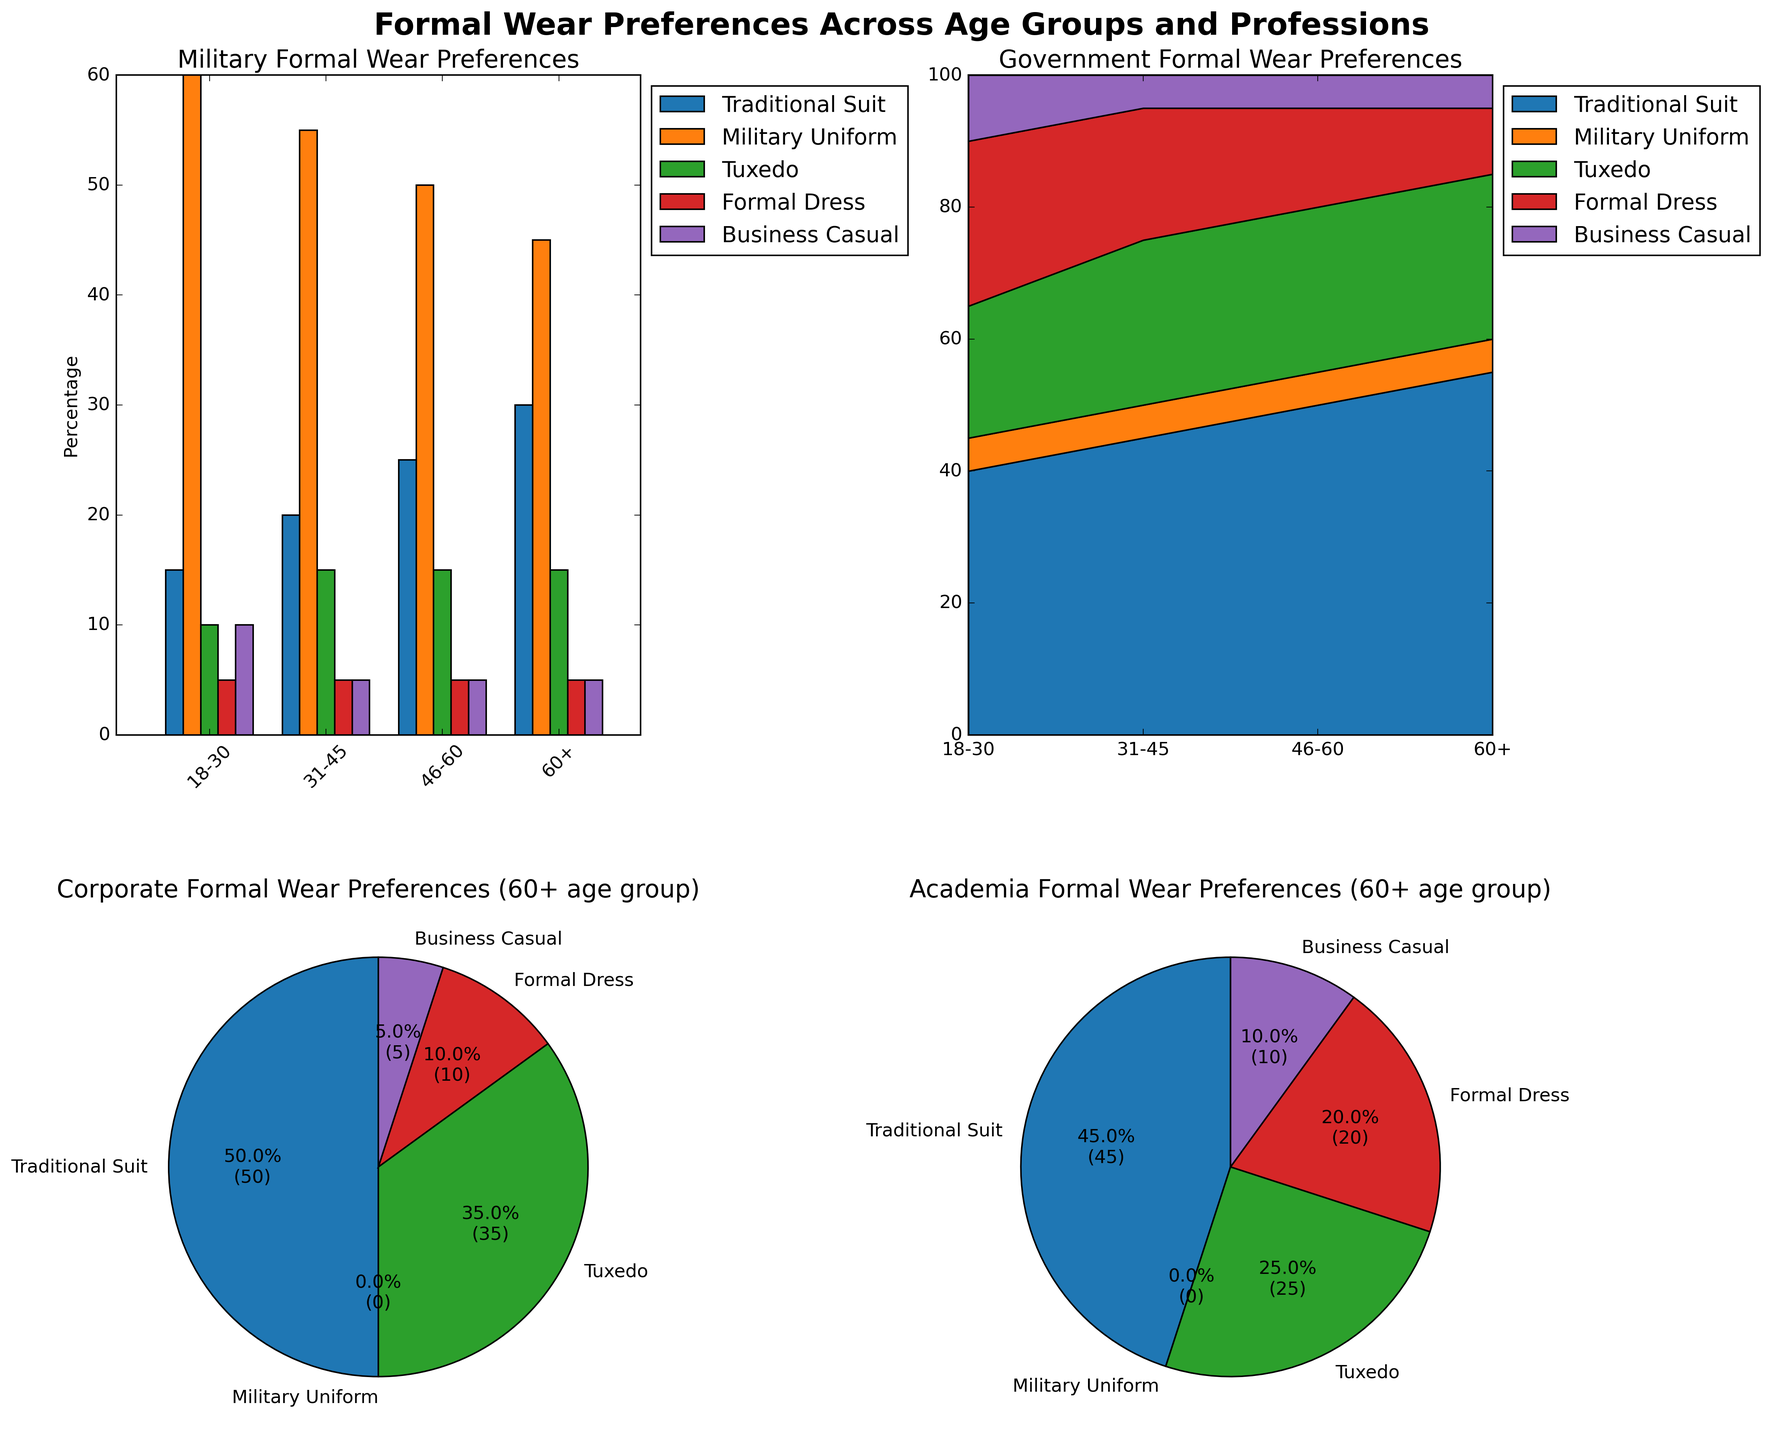What is the title of the figure portraying military preferences? Look at the title directly on the subplot located in the top-left corner, which describes military preferences in formal wear
Answer: Military Formal Wear Preferences For the Military profession, which age group shows the highest preference for a traditional suit? Examine the bar heights corresponding to the category 'Traditional Suit' in the bar plot for different age groups. The highest percentage is for the age group '60+'
Answer: 60+ Which profession has the highest preference for a Formal Dress in the 18-30 age group? Compare the height of the bars or slices in different professions subplots for the 18-30 age group under 'Formal Dress'. The Government profession has the highest preference
Answer: Government What is the overall trend in military uniform preference among different age groups in the Military profession? Check the bar heights for the 'Military Uniform' category across various age groups in the Military subplot. There's a decreasing trend from 60% to 45% as age increases
Answer: Decreasing For the Government profession, which age group shows the lowest preference for Business Casual wear? Observe the segments representing Business Casual wear in the stacked area plot for the Government profession. All age groups have a consistent value of 5% for Business Casual wear, thus they are equally the lowest
Answer: All age groups equally By how much does preference for Business Casual wear in the Academy profession change from the 18-30 age group to the 60+ age group? Determine the values for Business Casual wear in the Academy bar plot for the 18-30 and 60+ age groups: 30% and 10%. The difference is 30% - 10% = 20%
Answer: 20% Which type of formal wear has the highest overall preference in the Government profession? Notice the largest segment size in the stacked area plot for the Government profession. The 'Traditional Suit' category stands out as the most prominent
Answer: Traditional Suit In the pie chart for Corporate formal wear preferences (60+ age group), which category has the smallest proportion? Look at the smallest slice of the pie chart for Corporate formal wear preferences for the 60+ age group. The 'Formal Dress' category has the smallest proportion
Answer: Formal Dress 